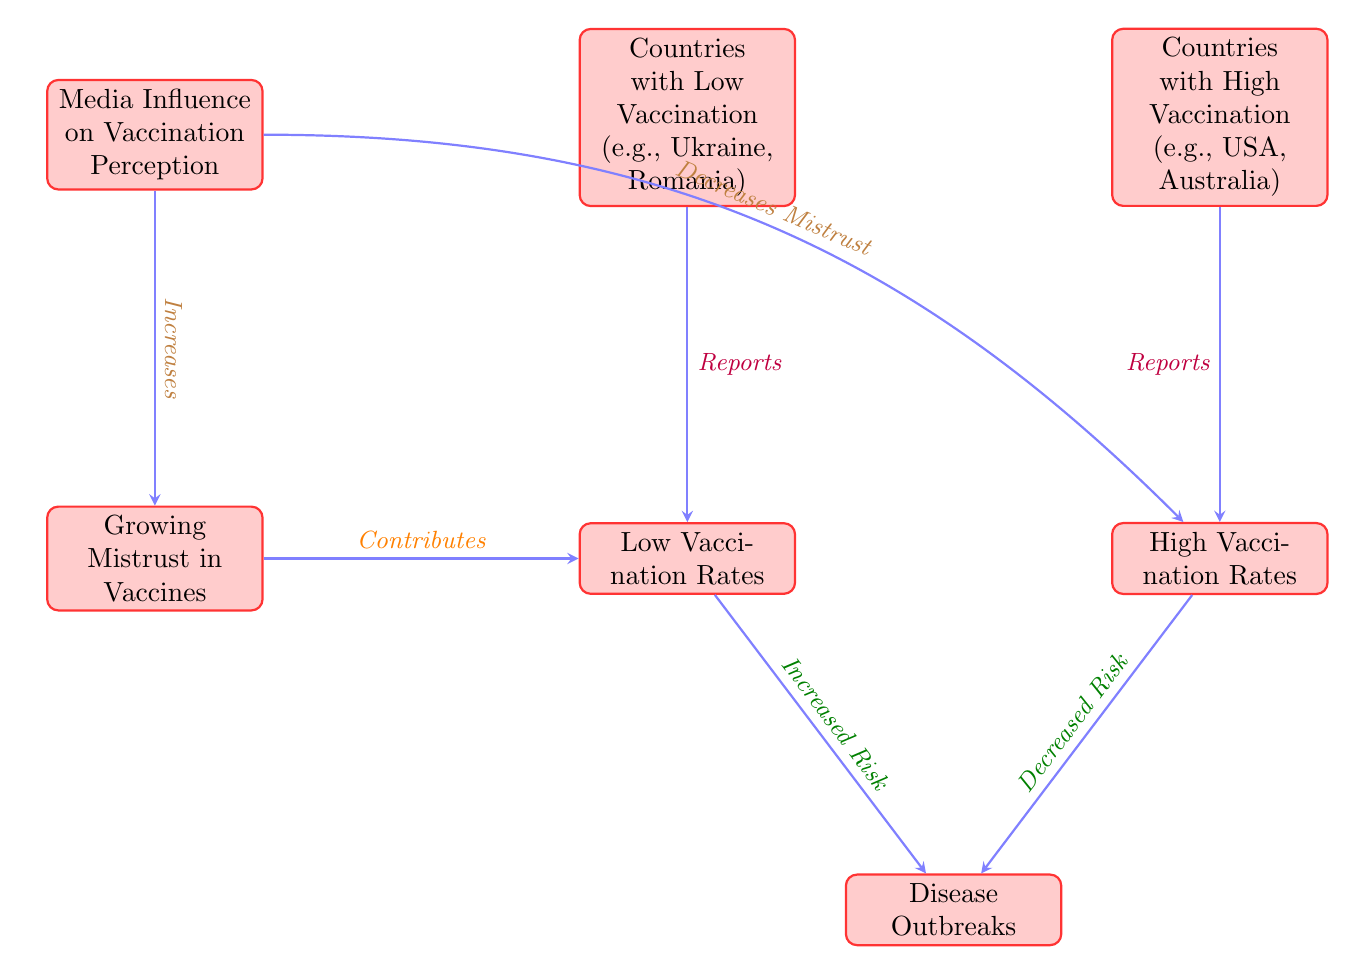What are the two categories of vaccination rates shown in the diagram? The diagram highlights two categories: "Low Vaccination Rates" and "High Vaccination Rates." These are represented as distinct nodes in the diagram, providing a clear comparison of vaccination levels.
Answer: Low Vaccination Rates, High Vaccination Rates Which countries are listed under low vaccination rates? The diagram specifies two countries associated with low vaccination rates: Ukraine and Romania. These countries are noted in the node above the "Low Vaccination Rates" category.
Answer: Ukraine, Romania What is the relationship between low vaccination rates and disease outbreaks? The diagram indicates that low vaccination rates result in an "Increased Risk" of disease outbreaks, indicated by the directed arrow pointing from "Low Vaccination Rates" to "Disease Outbreaks."
Answer: Increased Risk How does media influence vaccination perception toward high vaccination rates? The diagram shows that media decreases mistrust associated with vaccines, which is represented by the arrow flowing from "Media Influence on Vaccination Perception" to "High Vaccination Rates." Linked reasoning indicates that media positively affects vaccination rates.
Answer: Decreases Mistrust What is the implication of growing mistrust in vaccines according to the diagram? The diagram depicts that growing mistrust contributes to low vaccination rates, indicating that as mistrust rises, fewer people vaccinate. This relationship is shown by the directed arrow pointing from "Growing Mistrust in Vaccines" to "Low Vaccination Rates."
Answer: Contributes to Low Vaccination Rates What type of influence does media exert on vaccination perception as per the diagram? The diagram shows that media has a two-fold influence: it increases mistrust in low vaccination scenarios and decreases mistrust in high vaccination scenarios, indicating a complex role in shaping perceptions.
Answer: Increases, Decreases How many countries are specifically mentioned in relation to vaccination rates? The diagram features a total of four countries mentioned: two under low vaccination rates (Ukraine and Romania) and two under high vaccination rates (USA and Australia), which contributes to a clearer understanding of vaccination distribution across countries.
Answer: Four What does the arrow between "High Vaccination Rates" and "Disease Outbreaks" signify? The arrow connects "High Vaccination Rates" to "Disease Outbreaks" and states "Decreased Risk," indicating that higher vaccination rates are associated with a lower likelihood of disease outbreaks according to the diagram's representation.
Answer: Decreased Risk 